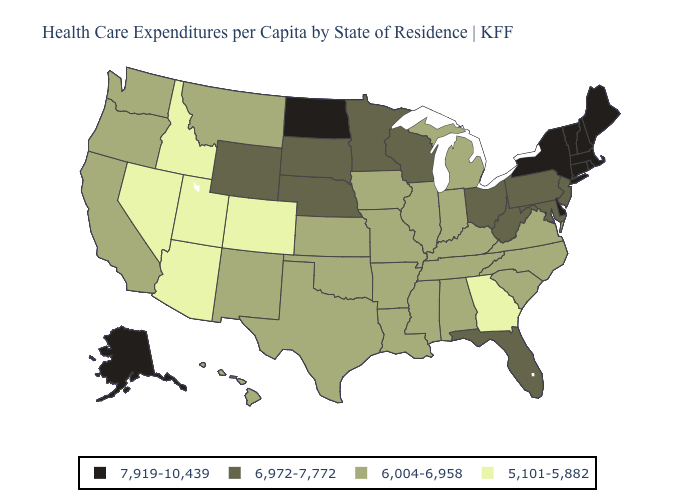Among the states that border Utah , does New Mexico have the highest value?
Keep it brief. No. Name the states that have a value in the range 5,101-5,882?
Write a very short answer. Arizona, Colorado, Georgia, Idaho, Nevada, Utah. Does Arizona have the highest value in the West?
Be succinct. No. Among the states that border Kentucky , does Ohio have the lowest value?
Short answer required. No. Does Tennessee have a lower value than Kansas?
Be succinct. No. Among the states that border California , does Oregon have the lowest value?
Be succinct. No. Among the states that border Kentucky , does West Virginia have the lowest value?
Give a very brief answer. No. What is the lowest value in the USA?
Be succinct. 5,101-5,882. Name the states that have a value in the range 7,919-10,439?
Keep it brief. Alaska, Connecticut, Delaware, Maine, Massachusetts, New Hampshire, New York, North Dakota, Rhode Island, Vermont. What is the value of Texas?
Quick response, please. 6,004-6,958. Which states have the lowest value in the USA?
Write a very short answer. Arizona, Colorado, Georgia, Idaho, Nevada, Utah. Name the states that have a value in the range 6,972-7,772?
Give a very brief answer. Florida, Maryland, Minnesota, Nebraska, New Jersey, Ohio, Pennsylvania, South Dakota, West Virginia, Wisconsin, Wyoming. Which states hav the highest value in the South?
Concise answer only. Delaware. Name the states that have a value in the range 6,972-7,772?
Short answer required. Florida, Maryland, Minnesota, Nebraska, New Jersey, Ohio, Pennsylvania, South Dakota, West Virginia, Wisconsin, Wyoming. Which states have the lowest value in the USA?
Quick response, please. Arizona, Colorado, Georgia, Idaho, Nevada, Utah. 